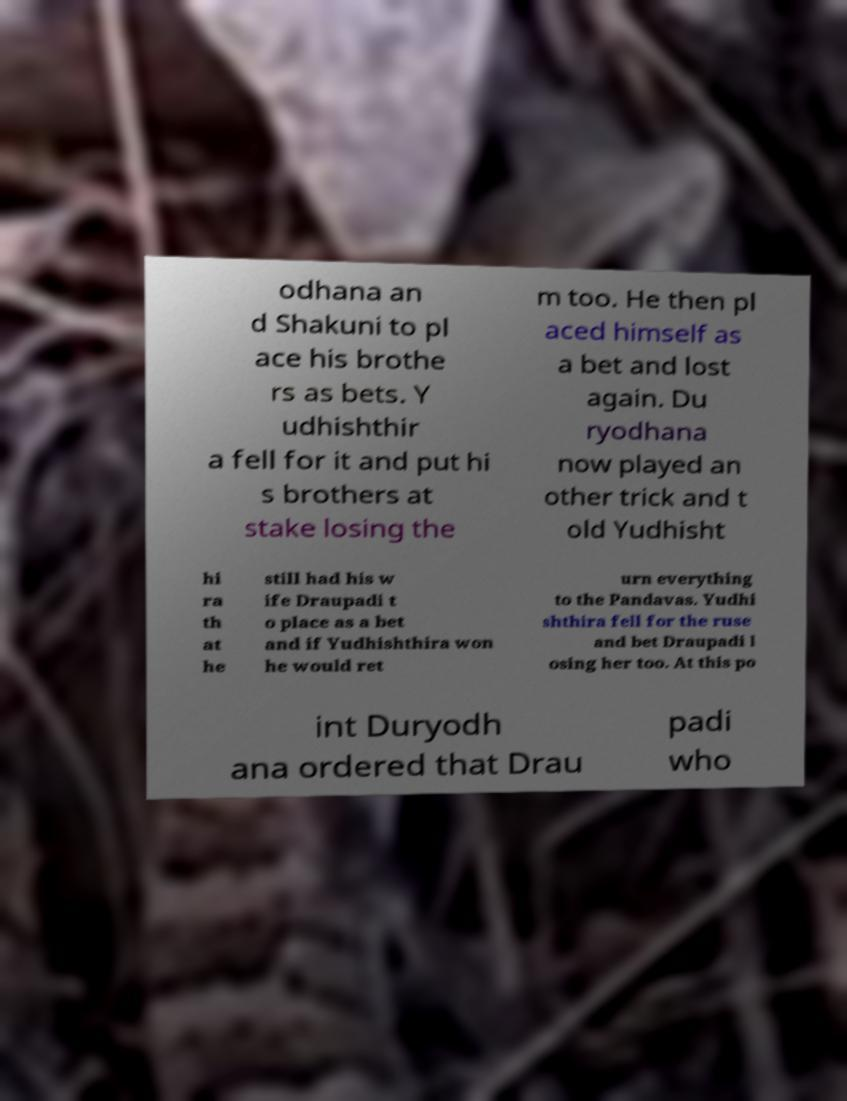There's text embedded in this image that I need extracted. Can you transcribe it verbatim? odhana an d Shakuni to pl ace his brothe rs as bets. Y udhishthir a fell for it and put hi s brothers at stake losing the m too. He then pl aced himself as a bet and lost again. Du ryodhana now played an other trick and t old Yudhisht hi ra th at he still had his w ife Draupadi t o place as a bet and if Yudhishthira won he would ret urn everything to the Pandavas. Yudhi shthira fell for the ruse and bet Draupadi l osing her too. At this po int Duryodh ana ordered that Drau padi who 